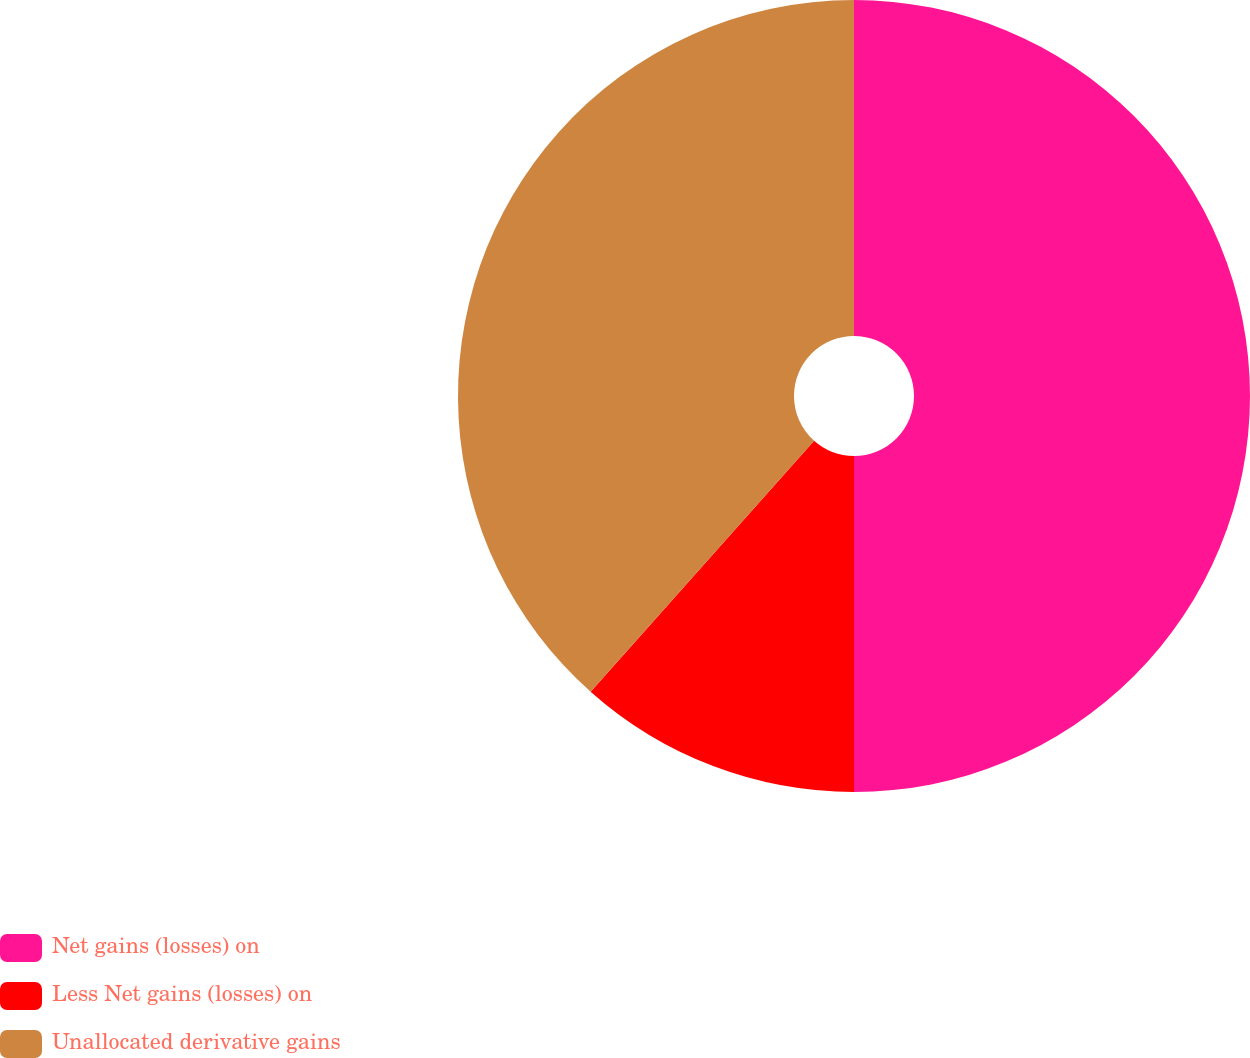<chart> <loc_0><loc_0><loc_500><loc_500><pie_chart><fcel>Net gains (losses) on<fcel>Less Net gains (losses) on<fcel>Unallocated derivative gains<nl><fcel>50.0%<fcel>11.58%<fcel>38.42%<nl></chart> 